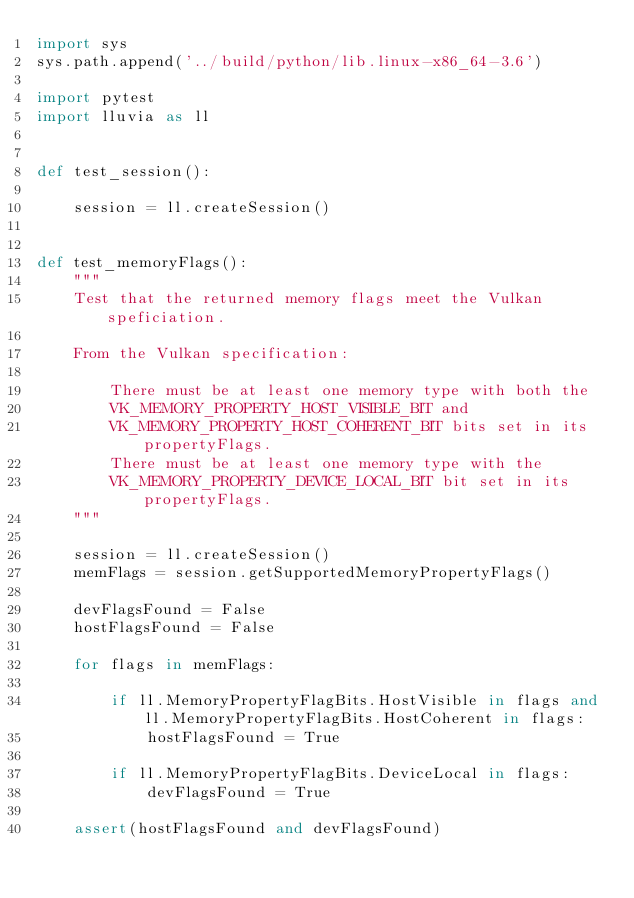Convert code to text. <code><loc_0><loc_0><loc_500><loc_500><_Python_>import sys
sys.path.append('../build/python/lib.linux-x86_64-3.6')

import pytest
import lluvia as ll


def test_session():

    session = ll.createSession()


def test_memoryFlags():
    """
    Test that the returned memory flags meet the Vulkan speficiation.

    From the Vulkan specification:

        There must be at least one memory type with both the
        VK_MEMORY_PROPERTY_HOST_VISIBLE_BIT and
        VK_MEMORY_PROPERTY_HOST_COHERENT_BIT bits set in its propertyFlags.
        There must be at least one memory type with the
        VK_MEMORY_PROPERTY_DEVICE_LOCAL_BIT bit set in its propertyFlags.
    """

    session = ll.createSession()
    memFlags = session.getSupportedMemoryPropertyFlags()

    devFlagsFound = False
    hostFlagsFound = False

    for flags in memFlags:

        if ll.MemoryPropertyFlagBits.HostVisible in flags and ll.MemoryPropertyFlagBits.HostCoherent in flags:
            hostFlagsFound = True

        if ll.MemoryPropertyFlagBits.DeviceLocal in flags:
            devFlagsFound = True

    assert(hostFlagsFound and devFlagsFound)
</code> 